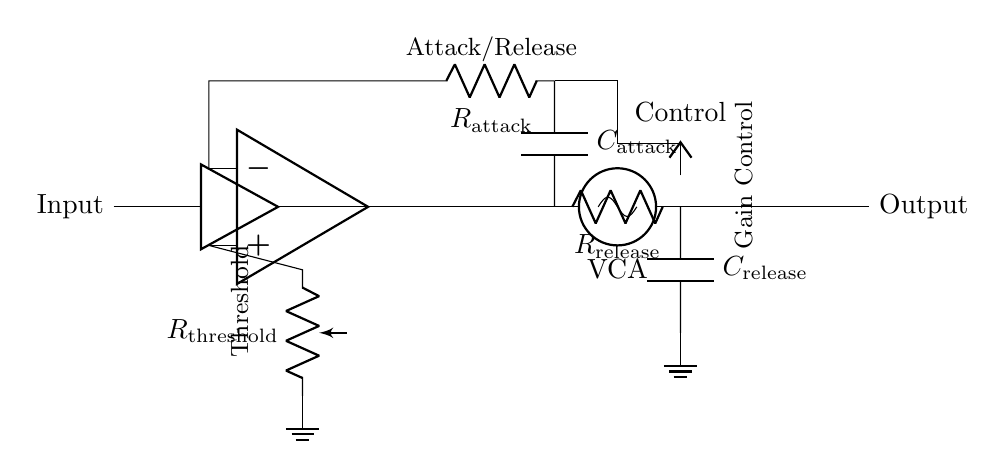What is the role of the op-amp in this circuit? The op-amp acts as a comparator that compares the input signal with the threshold set by the potentiometer. If the input signal exceeds the threshold, the op-amp outputs a control signal to adjust the gain of the VCA.
Answer: Comparator What is the component labeled as VCA? VCA stands for Voltage Controlled Amplifier, which is the component that adjusts the gain of the audio signal based on the control voltage received from the op-amp.
Answer: Voltage Controlled Amplifier What are the components used for attack and release in the circuit? The attack and release are managed by the resistor and capacitor combinations (R_attack, C_attack and R_release, C_release). The resistors and capacitors create time constants which influence how quickly the gate responds to changes in sound levels.
Answer: Resistor and Capacitor What is the function of the potentiometer in this noise gate circuit? The potentiometer is used to set the threshold level for the noise gate, determining the level above which the gate opens to allow audio signals to pass through.
Answer: Threshold Adjustment What is indicated by the term "ground" in the circuit diagram? Ground indicates a reference point in the circuit for electrical potential, typically at zero volts, where current may return. It serves as a common return path for current and stabilizes the circuit.
Answer: Zero volts What happens when the input signal is below the threshold? When the input signal is below the threshold, the control signal from the op-amp to the VCA remains low, effectively muting or reducing the output signal, thus minimizing unwanted background noise.
Answer: Muted Output 